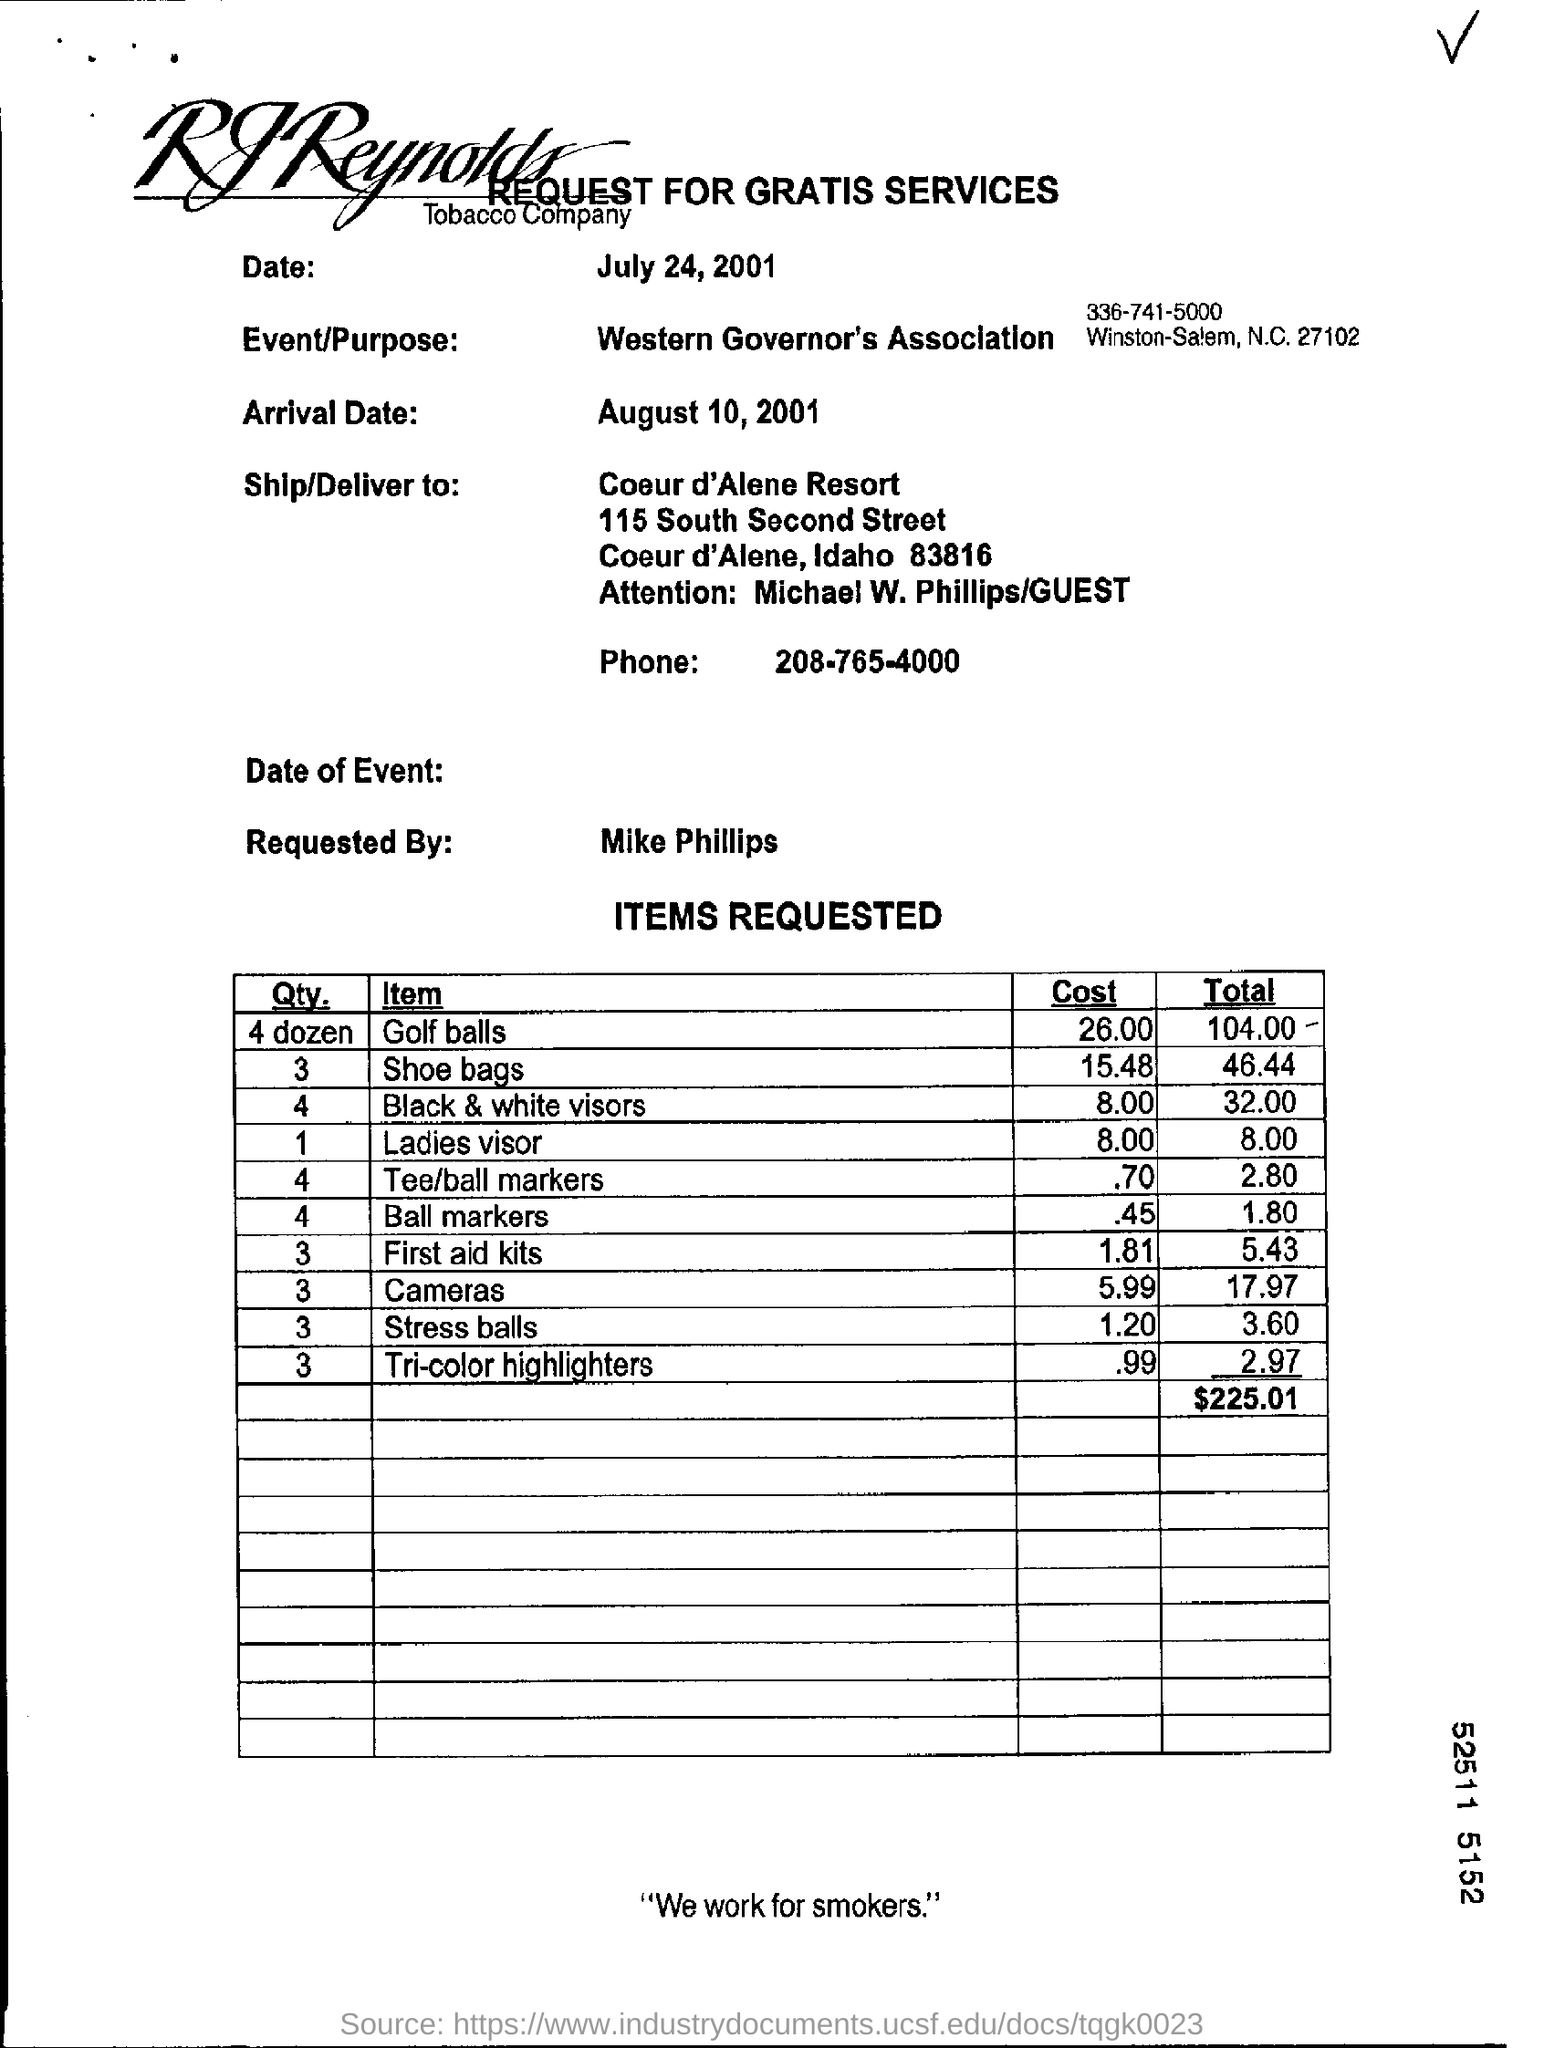Outline some significant characteristics in this image. The purpose of the event hosted by the Western Governor's Association is to provide information about a particular topic or issue. This is a request form for gratuitous services. The arrival date is August 10, 2001. The phone number in the document is 208-765-4000. 